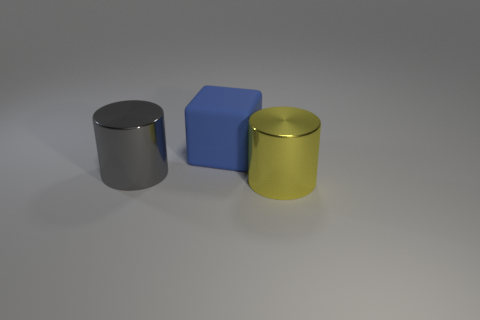How many large things are on the right side of the gray cylinder and in front of the big blue block?
Give a very brief answer. 1. Does the metal cylinder left of the big yellow thing have the same size as the cylinder that is on the right side of the rubber thing?
Offer a very short reply. Yes. What is the color of the metal cylinder that is in front of the gray metallic cylinder?
Make the answer very short. Yellow. There is a big object that is behind the large shiny cylinder that is behind the yellow cylinder; what is it made of?
Your answer should be very brief. Rubber. What is the shape of the big yellow object?
Ensure brevity in your answer.  Cylinder. There is a big yellow object that is the same shape as the large gray object; what is its material?
Provide a succinct answer. Metal. What number of other shiny cylinders are the same size as the gray cylinder?
Keep it short and to the point. 1. There is a cylinder on the left side of the yellow thing; are there any blue blocks that are in front of it?
Your response must be concise. No. What number of blue things are either rubber things or tiny cubes?
Your answer should be compact. 1. The big rubber object is what color?
Provide a short and direct response. Blue. 